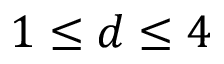<formula> <loc_0><loc_0><loc_500><loc_500>1 \leq d \leq 4</formula> 